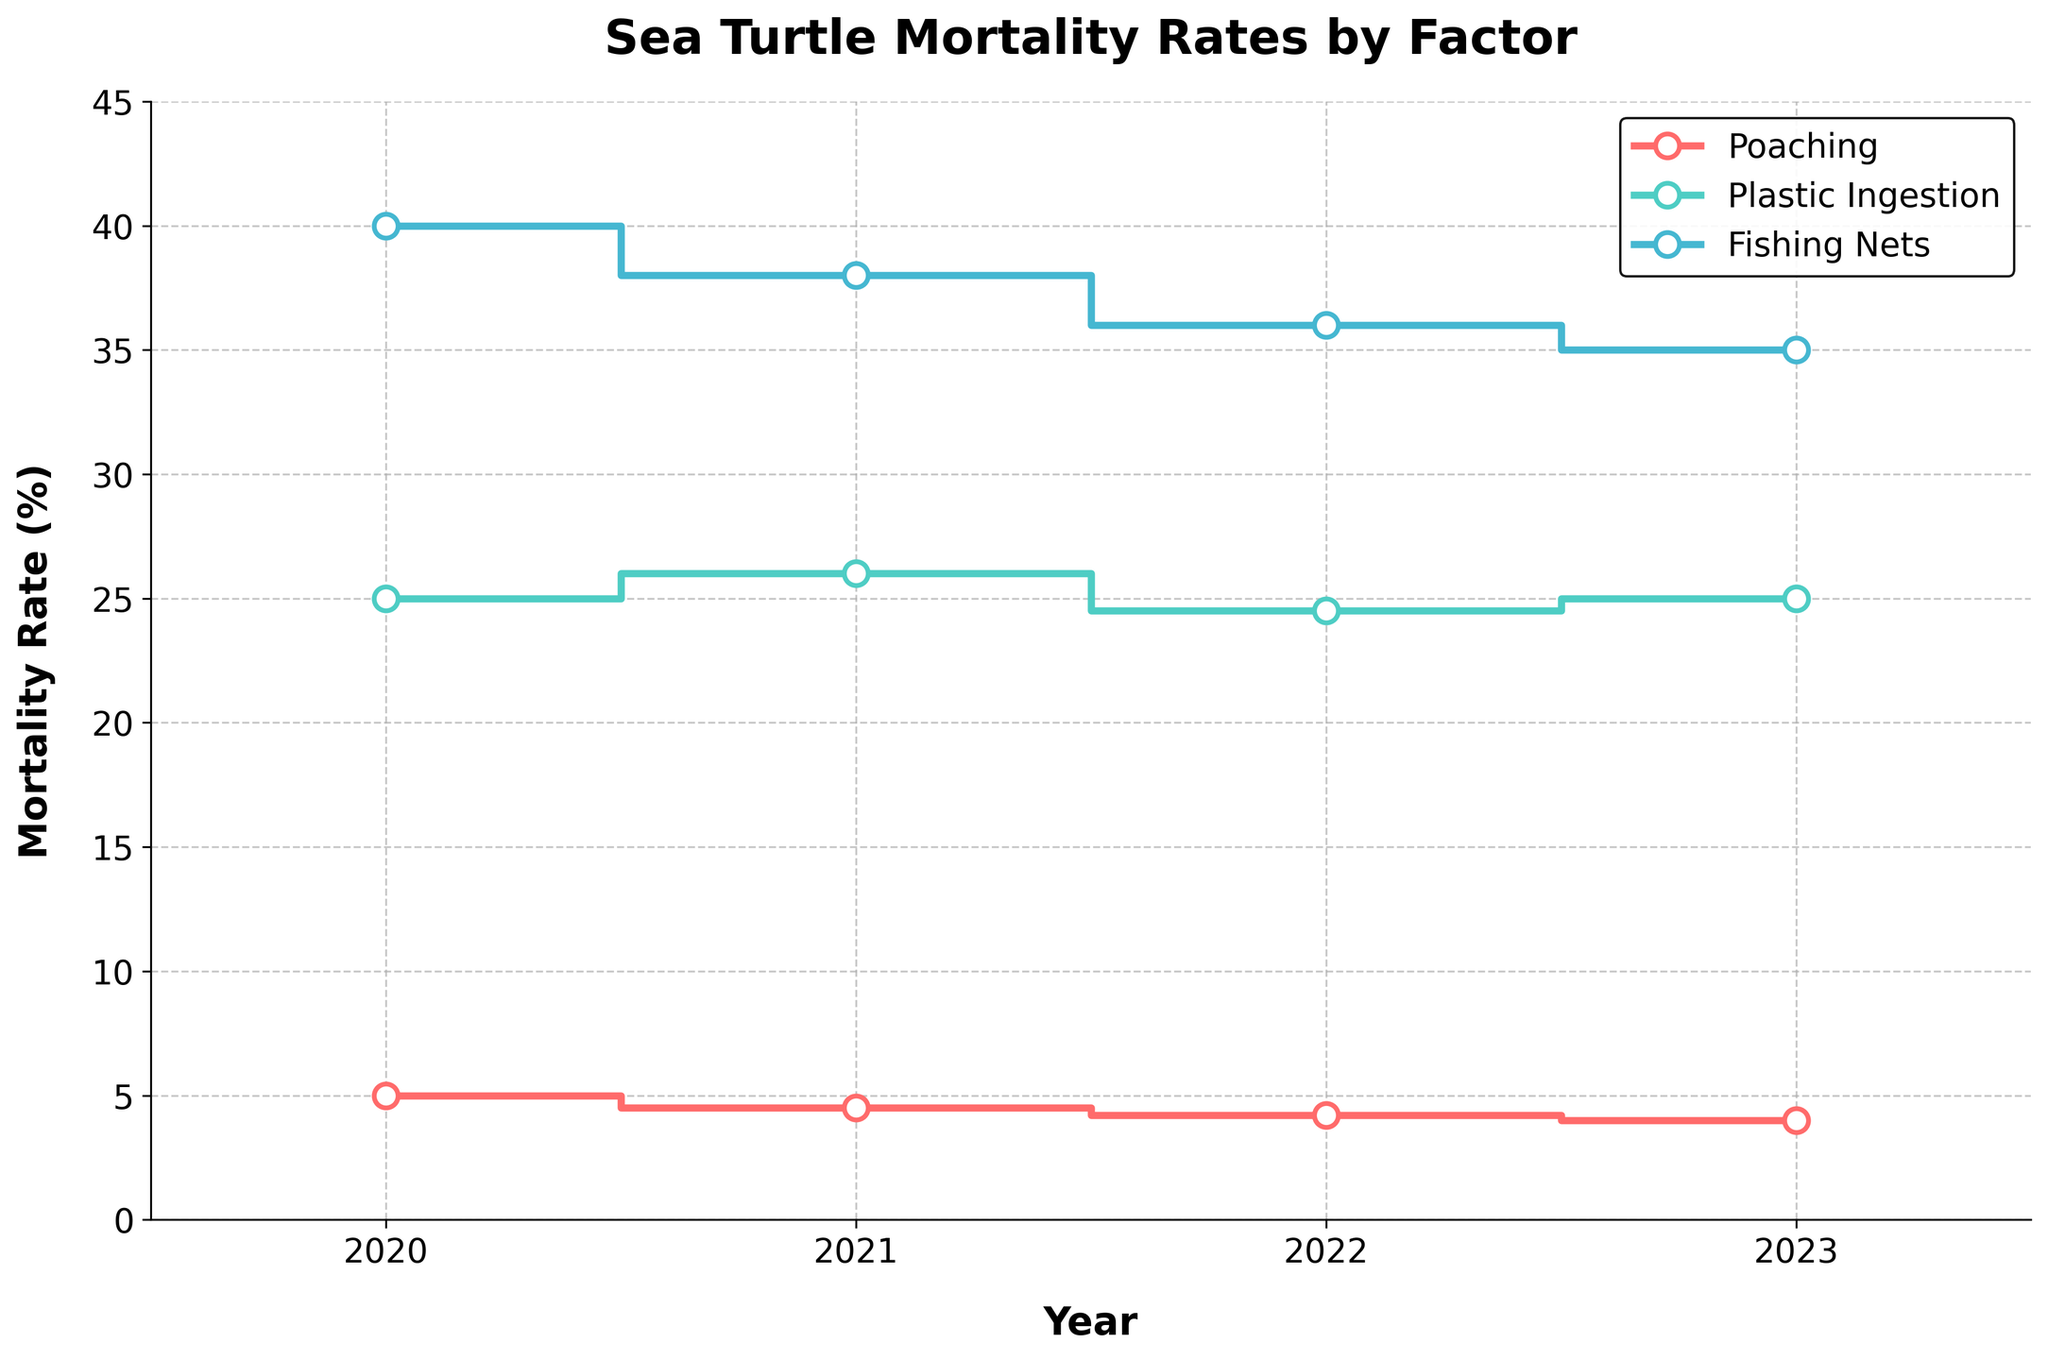What years are covered in the title of the plot? The title of the plot is "Sea Turtle Mortality Rates by Factor". This doesn't specify any years, but looking at the x-axis, the years covered are from 2020 to 2023.
Answer: 2020 to 2023 What is the mortality rate for plastic ingestion in 2021? The step representing plastic ingestion in 2021 can be identified by observing the point where the line with the green color intersects the year 2021 on the x-axis. This point is at a value of 26% on the y-axis.
Answer: 26% How does the mortality rate from poaching in 2023 compare to 2020? The poaching mortality rate for 2020 is 5%, and for 2023 it is 4%. Thus, the rate decreased by 1 percentage point from 2020 to 2023.
Answer: Decreased by 1% What is the average mortality rate for fishing nets over the four years? The mortality rates for fishing nets over the years 2020 to 2023 are 40%, 38%, 36%, and 35% respectively. The average can be calculated as (40 + 38 + 36 + 35) / 4 = 149 / 4 = 37.25.
Answer: 37.25% Which factor had the highest mortality rate across all years, and in what year? Observing the highest points across the factors, fishing nets had the highest mortality rate at 40% in the year 2020.
Answer: Fishing nets in 2020 Which mortality rate trend is the most stable from 2020 to 2023? By observing the lines, we see that the poaching mortality rate decreases slightly each year compared to plastic ingestion and fishing nets, which have more fluctuation. The stability can be seen in the slight gradient change in the line.
Answer: Poaching By how much did the mortality rate from plastic ingestion change from 2020 to 2023? The mortality rate from plastic ingestion was 25% in 2020 and 2023. Thus, the mortality rate from plastic ingestion did not change.
Answer: 0% Which year saw the biggest drop in the mortality rate for fishing nets, and what was the difference? By comparing the mortality rates year over year for fishing nets: 2020 to 2021 (40% to 38%), 2021 to 2022 (38% to 36%), and 2022 to 2023 (36% to 35%), the biggest drop is from 2020 to 2021 with a difference of 2%.
Answer: 2021 with a drop of 2% 